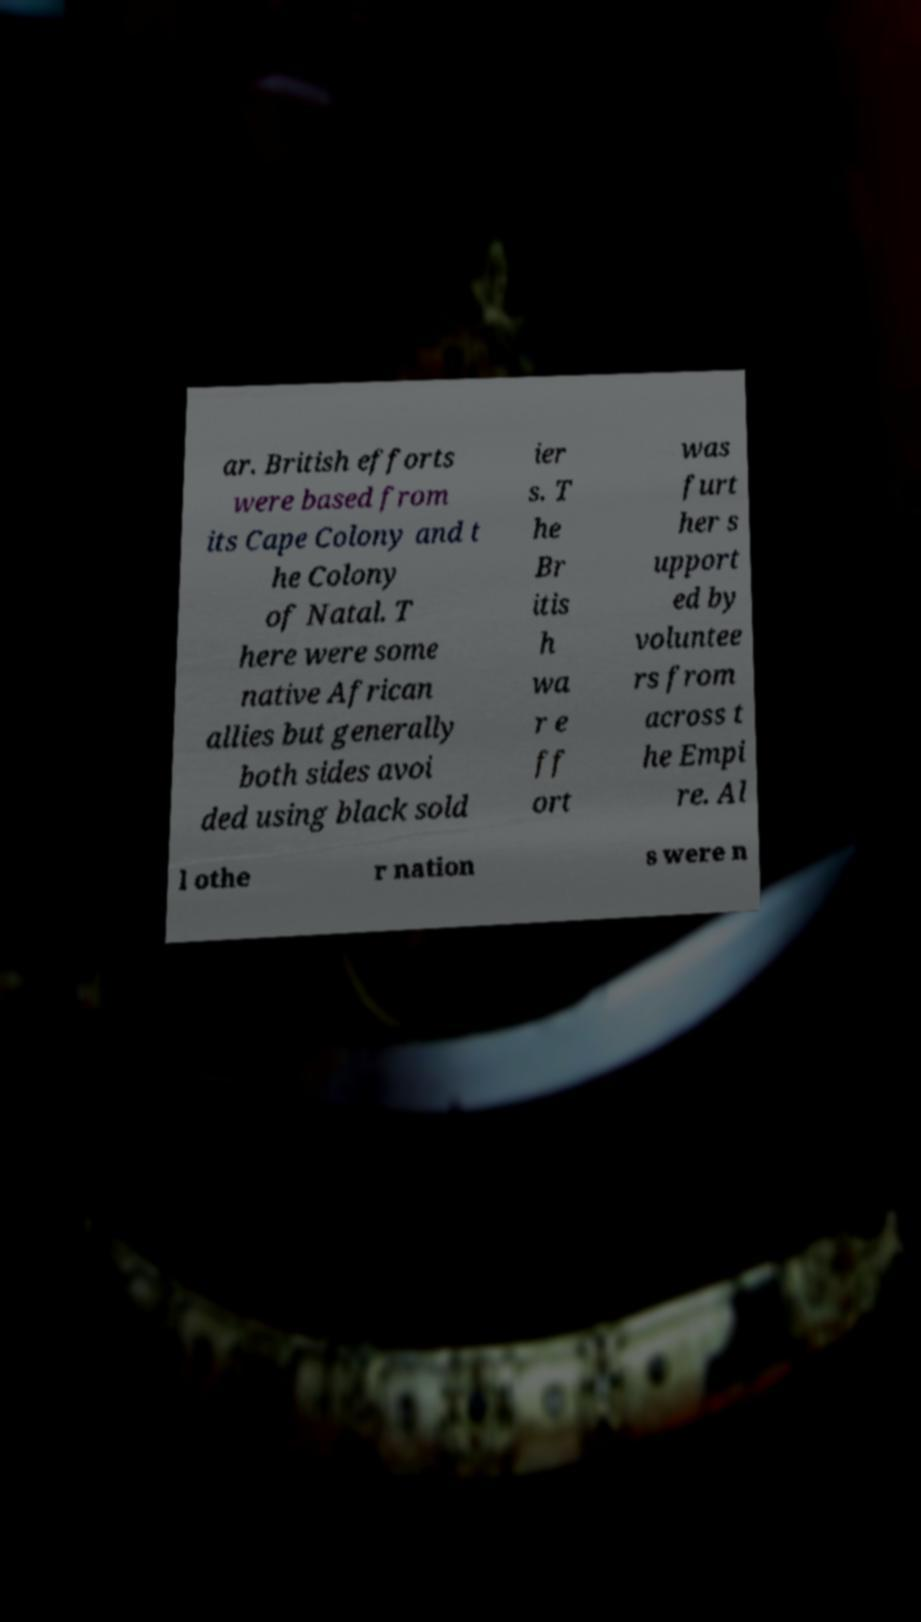Could you extract and type out the text from this image? ar. British efforts were based from its Cape Colony and t he Colony of Natal. T here were some native African allies but generally both sides avoi ded using black sold ier s. T he Br itis h wa r e ff ort was furt her s upport ed by voluntee rs from across t he Empi re. Al l othe r nation s were n 